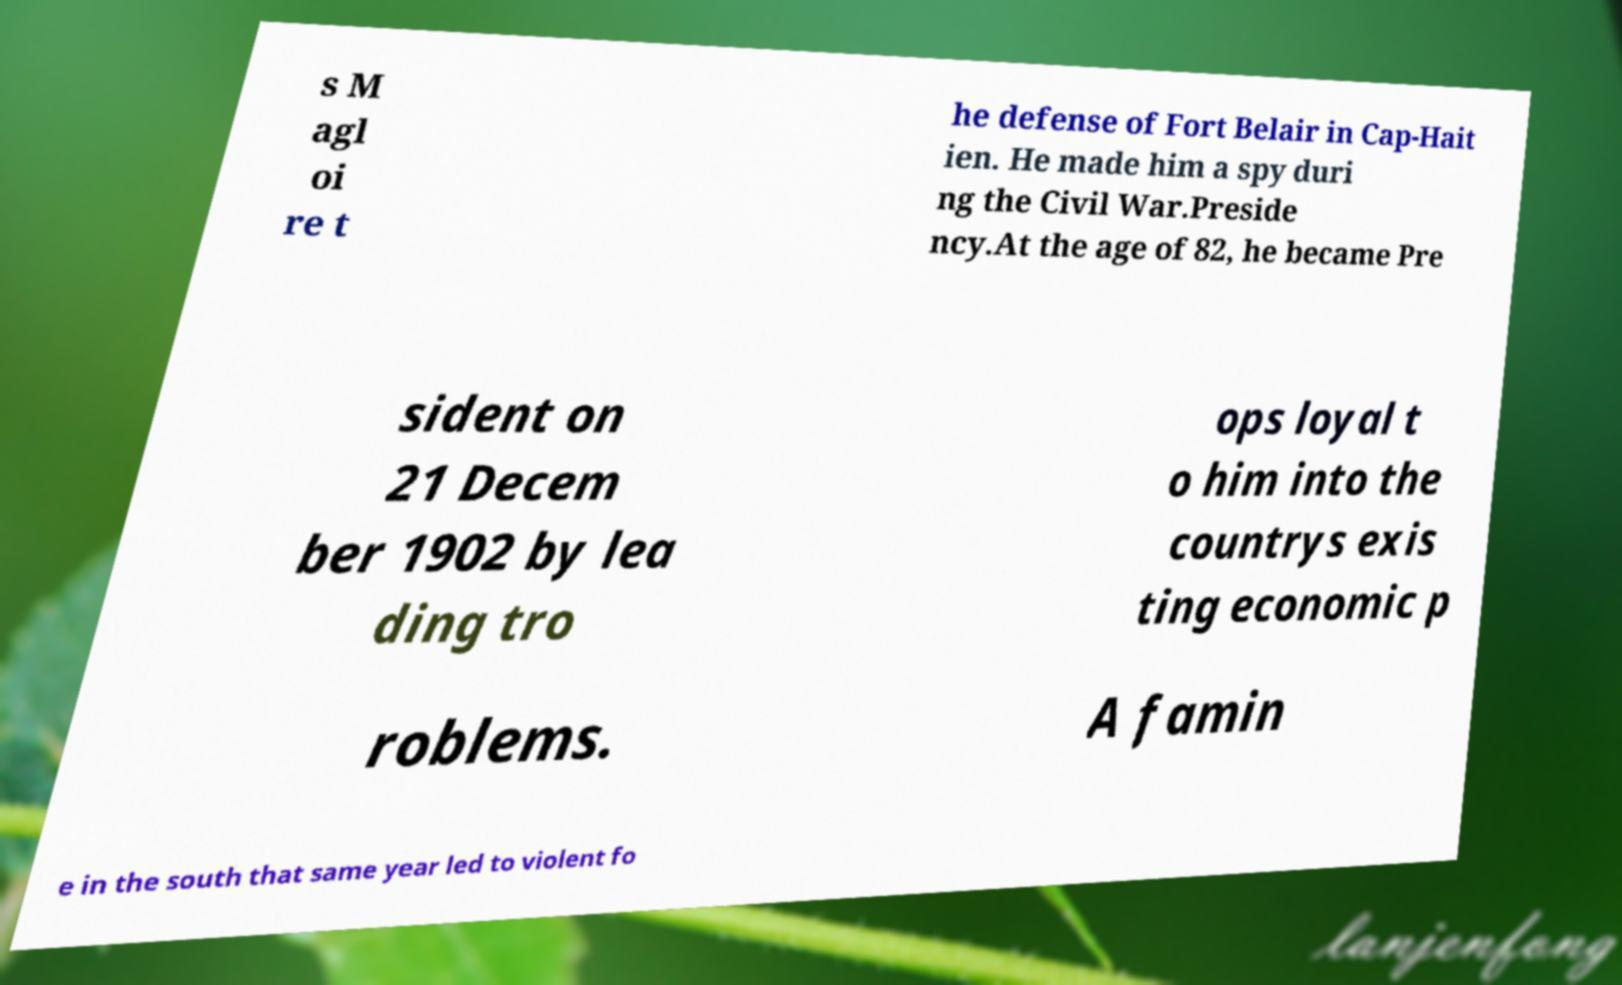Can you read and provide the text displayed in the image?This photo seems to have some interesting text. Can you extract and type it out for me? s M agl oi re t he defense of Fort Belair in Cap-Hait ien. He made him a spy duri ng the Civil War.Preside ncy.At the age of 82, he became Pre sident on 21 Decem ber 1902 by lea ding tro ops loyal t o him into the countrys exis ting economic p roblems. A famin e in the south that same year led to violent fo 